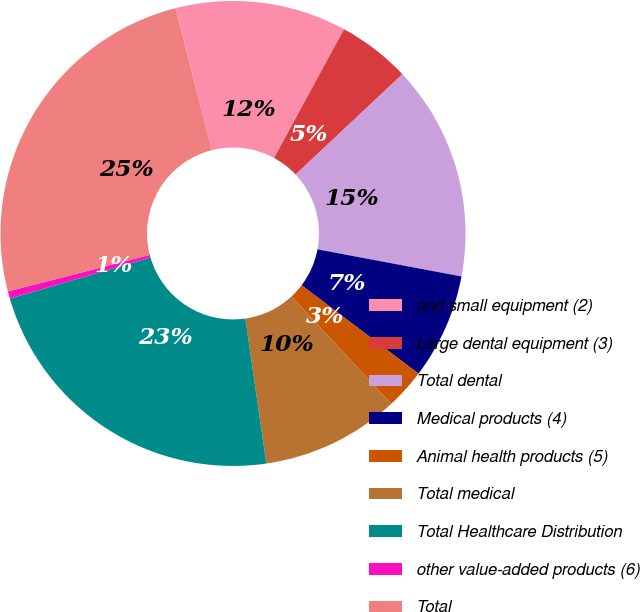<chart> <loc_0><loc_0><loc_500><loc_500><pie_chart><fcel>and small equipment (2)<fcel>Large dental equipment (3)<fcel>Total dental<fcel>Medical products (4)<fcel>Animal health products (5)<fcel>Total medical<fcel>Total Healthcare Distribution<fcel>other value-added products (6)<fcel>Total<nl><fcel>11.9%<fcel>5.07%<fcel>14.97%<fcel>7.34%<fcel>2.79%<fcel>9.62%<fcel>22.77%<fcel>0.51%<fcel>25.04%<nl></chart> 